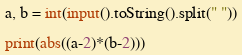Convert code to text. <code><loc_0><loc_0><loc_500><loc_500><_Python_>a, b = int(input().toString().split(" "))

print(abs((a-2)*(b-2)))</code> 